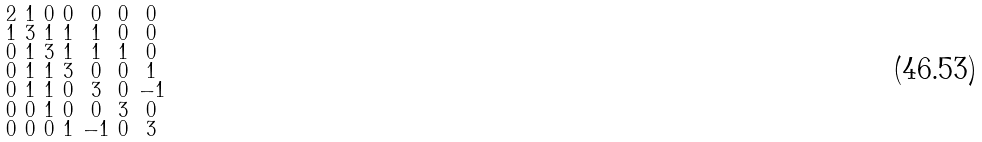Convert formula to latex. <formula><loc_0><loc_0><loc_500><loc_500>\begin{smallmatrix} 2 & 1 & 0 & 0 & 0 & 0 & 0 \\ 1 & 3 & 1 & 1 & 1 & 0 & 0 \\ 0 & 1 & 3 & 1 & 1 & 1 & 0 \\ 0 & 1 & 1 & 3 & 0 & 0 & 1 \\ 0 & 1 & 1 & 0 & 3 & 0 & - 1 \\ 0 & 0 & 1 & 0 & 0 & 3 & 0 \\ 0 & 0 & 0 & 1 & - 1 & 0 & 3 \end{smallmatrix}</formula> 